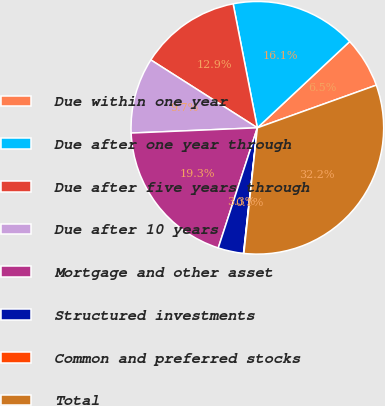<chart> <loc_0><loc_0><loc_500><loc_500><pie_chart><fcel>Due within one year<fcel>Due after one year through<fcel>Due after five years through<fcel>Due after 10 years<fcel>Mortgage and other asset<fcel>Structured investments<fcel>Common and preferred stocks<fcel>Total<nl><fcel>6.48%<fcel>16.11%<fcel>12.9%<fcel>9.69%<fcel>19.33%<fcel>3.26%<fcel>0.05%<fcel>32.18%<nl></chart> 